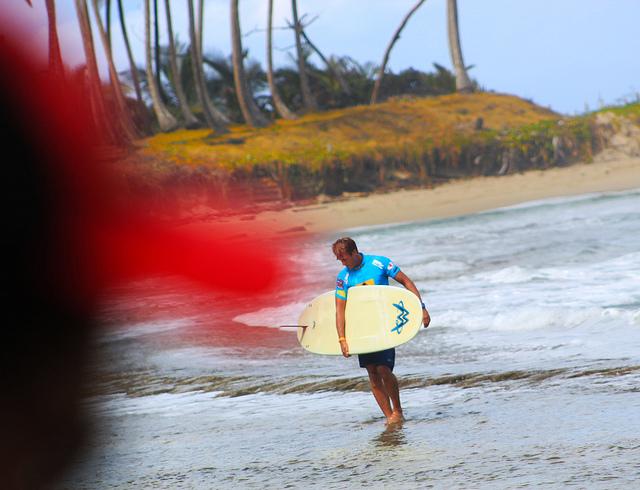Is this man surfing?
Concise answer only. Yes. Is that red tide?
Short answer required. No. What is obstructing the picture?
Keep it brief. Finger. 